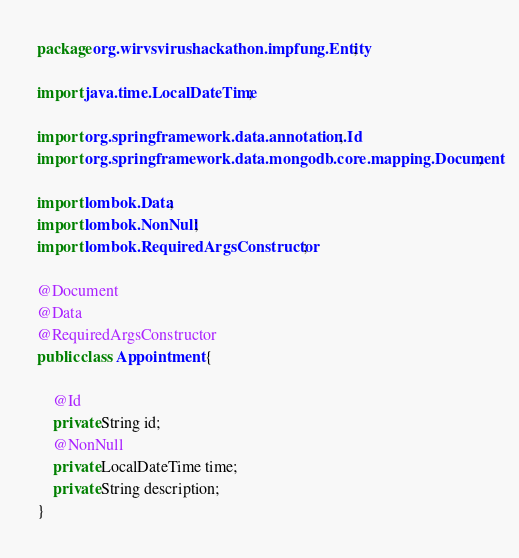<code> <loc_0><loc_0><loc_500><loc_500><_Java_>package org.wirvsvirushackathon.impfung.Entity;

import java.time.LocalDateTime;

import org.springframework.data.annotation.Id;
import org.springframework.data.mongodb.core.mapping.Document;

import lombok.Data;
import lombok.NonNull;
import lombok.RequiredArgsConstructor;

@Document
@Data
@RequiredArgsConstructor
public class Appointment {
	
	@Id
	private String id;
	@NonNull
	private LocalDateTime time;
	private String description;
}
</code> 